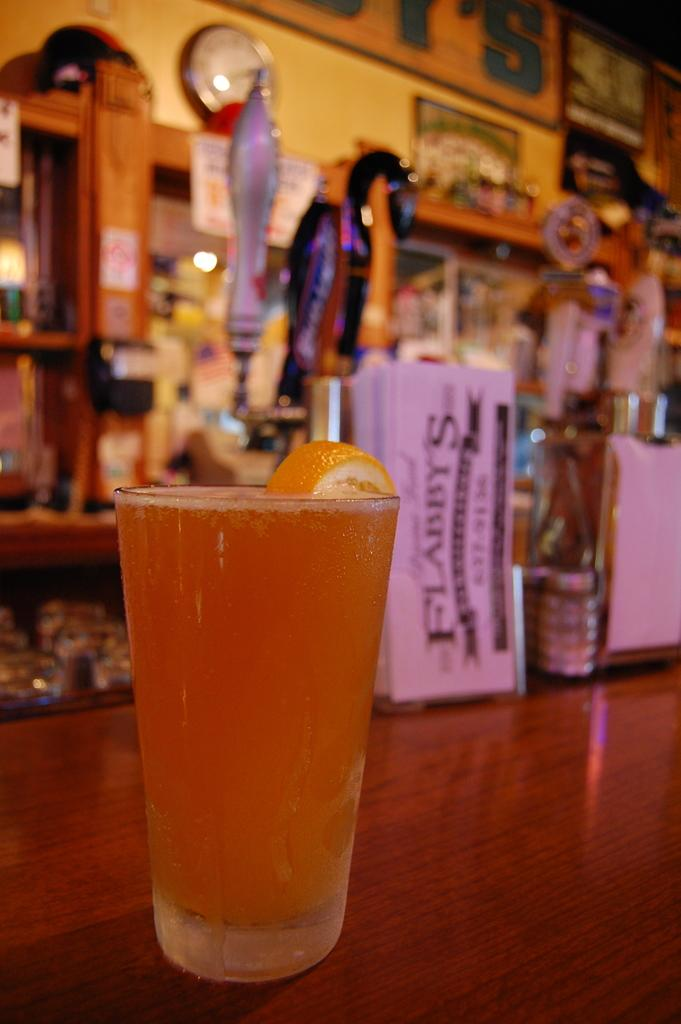<image>
Give a short and clear explanation of the subsequent image. A glass og light colored beer with a orange in it at Flabbys 